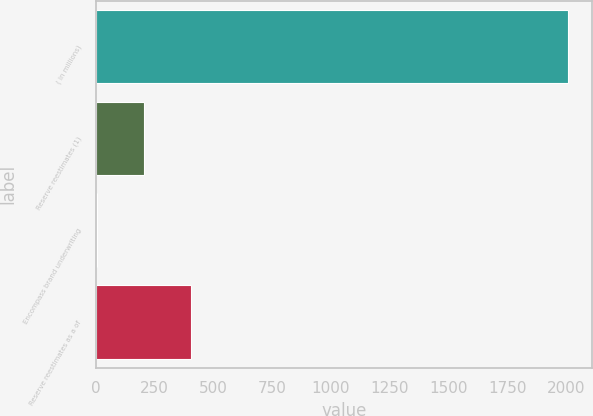Convert chart to OTSL. <chart><loc_0><loc_0><loc_500><loc_500><bar_chart><fcel>( in millions)<fcel>Reserve reestimates (1)<fcel>Encompass brand underwriting<fcel>Reserve reestimates as a of<nl><fcel>2009<fcel>205.4<fcel>5<fcel>405.8<nl></chart> 